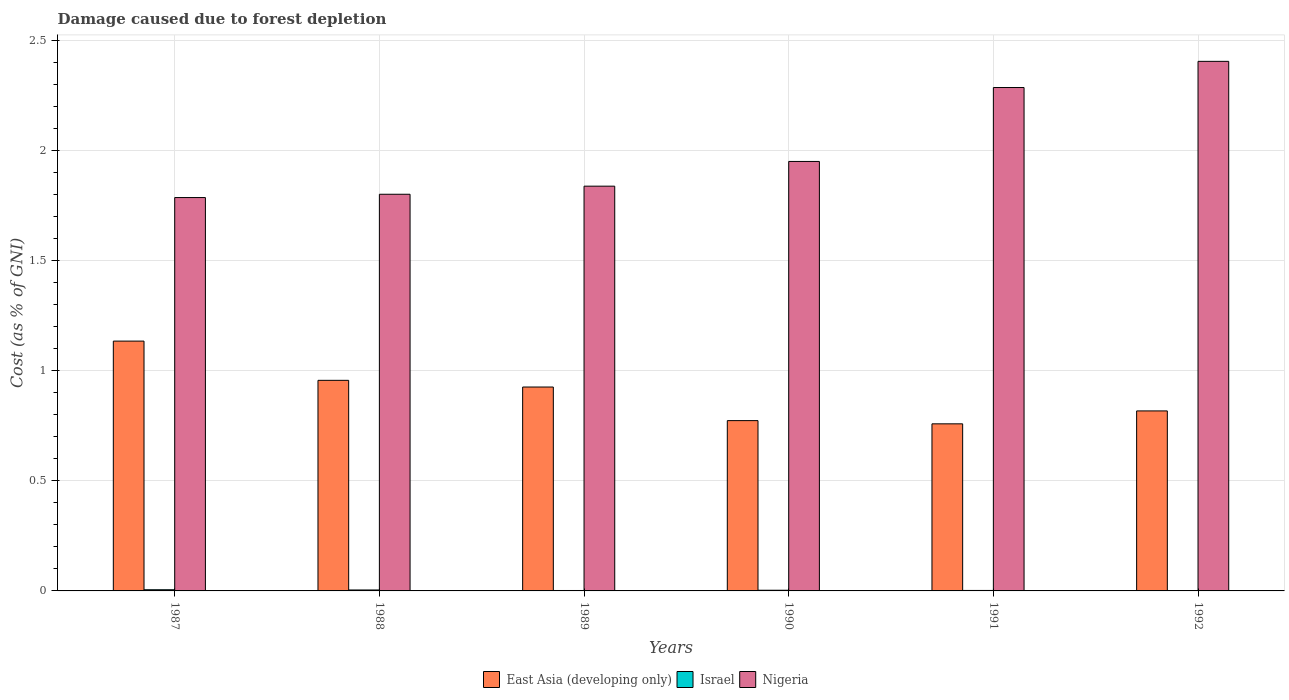How many groups of bars are there?
Your answer should be compact. 6. Are the number of bars per tick equal to the number of legend labels?
Make the answer very short. Yes. How many bars are there on the 6th tick from the left?
Give a very brief answer. 3. How many bars are there on the 1st tick from the right?
Provide a succinct answer. 3. What is the cost of damage caused due to forest depletion in East Asia (developing only) in 1989?
Keep it short and to the point. 0.93. Across all years, what is the maximum cost of damage caused due to forest depletion in East Asia (developing only)?
Give a very brief answer. 1.13. Across all years, what is the minimum cost of damage caused due to forest depletion in East Asia (developing only)?
Provide a succinct answer. 0.76. In which year was the cost of damage caused due to forest depletion in Israel maximum?
Your answer should be compact. 1987. What is the total cost of damage caused due to forest depletion in Nigeria in the graph?
Keep it short and to the point. 12.07. What is the difference between the cost of damage caused due to forest depletion in Israel in 1988 and that in 1992?
Your answer should be very brief. 0. What is the difference between the cost of damage caused due to forest depletion in Nigeria in 1988 and the cost of damage caused due to forest depletion in East Asia (developing only) in 1987?
Make the answer very short. 0.67. What is the average cost of damage caused due to forest depletion in East Asia (developing only) per year?
Offer a terse response. 0.89. In the year 1990, what is the difference between the cost of damage caused due to forest depletion in Israel and cost of damage caused due to forest depletion in Nigeria?
Provide a succinct answer. -1.95. What is the ratio of the cost of damage caused due to forest depletion in Nigeria in 1987 to that in 1988?
Offer a very short reply. 0.99. Is the cost of damage caused due to forest depletion in Nigeria in 1989 less than that in 1990?
Provide a succinct answer. Yes. What is the difference between the highest and the second highest cost of damage caused due to forest depletion in East Asia (developing only)?
Offer a terse response. 0.18. What is the difference between the highest and the lowest cost of damage caused due to forest depletion in Israel?
Keep it short and to the point. 0. Is the sum of the cost of damage caused due to forest depletion in Israel in 1988 and 1991 greater than the maximum cost of damage caused due to forest depletion in East Asia (developing only) across all years?
Give a very brief answer. No. Is it the case that in every year, the sum of the cost of damage caused due to forest depletion in Israel and cost of damage caused due to forest depletion in East Asia (developing only) is greater than the cost of damage caused due to forest depletion in Nigeria?
Offer a terse response. No. How many bars are there?
Offer a terse response. 18. Are all the bars in the graph horizontal?
Your answer should be very brief. No. What is the difference between two consecutive major ticks on the Y-axis?
Offer a very short reply. 0.5. Does the graph contain any zero values?
Your response must be concise. No. What is the title of the graph?
Give a very brief answer. Damage caused due to forest depletion. Does "Bahamas" appear as one of the legend labels in the graph?
Offer a very short reply. No. What is the label or title of the Y-axis?
Ensure brevity in your answer.  Cost (as % of GNI). What is the Cost (as % of GNI) in East Asia (developing only) in 1987?
Offer a very short reply. 1.13. What is the Cost (as % of GNI) of Israel in 1987?
Ensure brevity in your answer.  0.01. What is the Cost (as % of GNI) of Nigeria in 1987?
Provide a succinct answer. 1.79. What is the Cost (as % of GNI) in East Asia (developing only) in 1988?
Keep it short and to the point. 0.96. What is the Cost (as % of GNI) of Israel in 1988?
Give a very brief answer. 0. What is the Cost (as % of GNI) in Nigeria in 1988?
Your answer should be compact. 1.8. What is the Cost (as % of GNI) of East Asia (developing only) in 1989?
Provide a succinct answer. 0.93. What is the Cost (as % of GNI) in Israel in 1989?
Your answer should be compact. 0. What is the Cost (as % of GNI) of Nigeria in 1989?
Your answer should be compact. 1.84. What is the Cost (as % of GNI) in East Asia (developing only) in 1990?
Make the answer very short. 0.77. What is the Cost (as % of GNI) of Israel in 1990?
Offer a very short reply. 0. What is the Cost (as % of GNI) in Nigeria in 1990?
Keep it short and to the point. 1.95. What is the Cost (as % of GNI) in East Asia (developing only) in 1991?
Make the answer very short. 0.76. What is the Cost (as % of GNI) in Israel in 1991?
Keep it short and to the point. 0. What is the Cost (as % of GNI) in Nigeria in 1991?
Offer a very short reply. 2.29. What is the Cost (as % of GNI) in East Asia (developing only) in 1992?
Make the answer very short. 0.82. What is the Cost (as % of GNI) of Israel in 1992?
Your response must be concise. 0. What is the Cost (as % of GNI) of Nigeria in 1992?
Your answer should be compact. 2.41. Across all years, what is the maximum Cost (as % of GNI) in East Asia (developing only)?
Keep it short and to the point. 1.13. Across all years, what is the maximum Cost (as % of GNI) of Israel?
Your response must be concise. 0.01. Across all years, what is the maximum Cost (as % of GNI) of Nigeria?
Offer a terse response. 2.41. Across all years, what is the minimum Cost (as % of GNI) in East Asia (developing only)?
Ensure brevity in your answer.  0.76. Across all years, what is the minimum Cost (as % of GNI) in Israel?
Your answer should be very brief. 0. Across all years, what is the minimum Cost (as % of GNI) in Nigeria?
Offer a very short reply. 1.79. What is the total Cost (as % of GNI) of East Asia (developing only) in the graph?
Your answer should be compact. 5.37. What is the total Cost (as % of GNI) of Israel in the graph?
Offer a very short reply. 0.02. What is the total Cost (as % of GNI) in Nigeria in the graph?
Provide a succinct answer. 12.07. What is the difference between the Cost (as % of GNI) of East Asia (developing only) in 1987 and that in 1988?
Offer a terse response. 0.18. What is the difference between the Cost (as % of GNI) in Israel in 1987 and that in 1988?
Keep it short and to the point. 0. What is the difference between the Cost (as % of GNI) in Nigeria in 1987 and that in 1988?
Make the answer very short. -0.01. What is the difference between the Cost (as % of GNI) of East Asia (developing only) in 1987 and that in 1989?
Give a very brief answer. 0.21. What is the difference between the Cost (as % of GNI) in Israel in 1987 and that in 1989?
Make the answer very short. 0. What is the difference between the Cost (as % of GNI) in Nigeria in 1987 and that in 1989?
Offer a terse response. -0.05. What is the difference between the Cost (as % of GNI) of East Asia (developing only) in 1987 and that in 1990?
Provide a succinct answer. 0.36. What is the difference between the Cost (as % of GNI) in Israel in 1987 and that in 1990?
Make the answer very short. 0. What is the difference between the Cost (as % of GNI) of Nigeria in 1987 and that in 1990?
Your answer should be very brief. -0.16. What is the difference between the Cost (as % of GNI) in East Asia (developing only) in 1987 and that in 1991?
Offer a very short reply. 0.38. What is the difference between the Cost (as % of GNI) of Israel in 1987 and that in 1991?
Offer a terse response. 0. What is the difference between the Cost (as % of GNI) of Nigeria in 1987 and that in 1991?
Give a very brief answer. -0.5. What is the difference between the Cost (as % of GNI) of East Asia (developing only) in 1987 and that in 1992?
Make the answer very short. 0.32. What is the difference between the Cost (as % of GNI) in Israel in 1987 and that in 1992?
Ensure brevity in your answer.  0. What is the difference between the Cost (as % of GNI) in Nigeria in 1987 and that in 1992?
Your answer should be compact. -0.62. What is the difference between the Cost (as % of GNI) of East Asia (developing only) in 1988 and that in 1989?
Your response must be concise. 0.03. What is the difference between the Cost (as % of GNI) in Israel in 1988 and that in 1989?
Provide a succinct answer. 0. What is the difference between the Cost (as % of GNI) in Nigeria in 1988 and that in 1989?
Offer a terse response. -0.04. What is the difference between the Cost (as % of GNI) in East Asia (developing only) in 1988 and that in 1990?
Your response must be concise. 0.18. What is the difference between the Cost (as % of GNI) of Israel in 1988 and that in 1990?
Offer a terse response. 0. What is the difference between the Cost (as % of GNI) in Nigeria in 1988 and that in 1990?
Make the answer very short. -0.15. What is the difference between the Cost (as % of GNI) of East Asia (developing only) in 1988 and that in 1991?
Provide a short and direct response. 0.2. What is the difference between the Cost (as % of GNI) in Israel in 1988 and that in 1991?
Offer a very short reply. 0. What is the difference between the Cost (as % of GNI) in Nigeria in 1988 and that in 1991?
Offer a terse response. -0.48. What is the difference between the Cost (as % of GNI) of East Asia (developing only) in 1988 and that in 1992?
Give a very brief answer. 0.14. What is the difference between the Cost (as % of GNI) in Israel in 1988 and that in 1992?
Give a very brief answer. 0. What is the difference between the Cost (as % of GNI) in Nigeria in 1988 and that in 1992?
Keep it short and to the point. -0.6. What is the difference between the Cost (as % of GNI) in East Asia (developing only) in 1989 and that in 1990?
Make the answer very short. 0.15. What is the difference between the Cost (as % of GNI) of Israel in 1989 and that in 1990?
Make the answer very short. -0. What is the difference between the Cost (as % of GNI) of Nigeria in 1989 and that in 1990?
Your answer should be very brief. -0.11. What is the difference between the Cost (as % of GNI) in East Asia (developing only) in 1989 and that in 1991?
Offer a very short reply. 0.17. What is the difference between the Cost (as % of GNI) in Israel in 1989 and that in 1991?
Make the answer very short. -0. What is the difference between the Cost (as % of GNI) in Nigeria in 1989 and that in 1991?
Offer a terse response. -0.45. What is the difference between the Cost (as % of GNI) of East Asia (developing only) in 1989 and that in 1992?
Give a very brief answer. 0.11. What is the difference between the Cost (as % of GNI) in Israel in 1989 and that in 1992?
Offer a terse response. 0. What is the difference between the Cost (as % of GNI) of Nigeria in 1989 and that in 1992?
Your answer should be compact. -0.57. What is the difference between the Cost (as % of GNI) in East Asia (developing only) in 1990 and that in 1991?
Keep it short and to the point. 0.01. What is the difference between the Cost (as % of GNI) in Israel in 1990 and that in 1991?
Your answer should be compact. 0. What is the difference between the Cost (as % of GNI) in Nigeria in 1990 and that in 1991?
Keep it short and to the point. -0.34. What is the difference between the Cost (as % of GNI) of East Asia (developing only) in 1990 and that in 1992?
Provide a short and direct response. -0.04. What is the difference between the Cost (as % of GNI) in Israel in 1990 and that in 1992?
Give a very brief answer. 0. What is the difference between the Cost (as % of GNI) in Nigeria in 1990 and that in 1992?
Your answer should be very brief. -0.45. What is the difference between the Cost (as % of GNI) of East Asia (developing only) in 1991 and that in 1992?
Provide a succinct answer. -0.06. What is the difference between the Cost (as % of GNI) in Nigeria in 1991 and that in 1992?
Offer a terse response. -0.12. What is the difference between the Cost (as % of GNI) in East Asia (developing only) in 1987 and the Cost (as % of GNI) in Israel in 1988?
Your response must be concise. 1.13. What is the difference between the Cost (as % of GNI) of East Asia (developing only) in 1987 and the Cost (as % of GNI) of Nigeria in 1988?
Give a very brief answer. -0.67. What is the difference between the Cost (as % of GNI) of Israel in 1987 and the Cost (as % of GNI) of Nigeria in 1988?
Provide a succinct answer. -1.8. What is the difference between the Cost (as % of GNI) in East Asia (developing only) in 1987 and the Cost (as % of GNI) in Israel in 1989?
Provide a short and direct response. 1.13. What is the difference between the Cost (as % of GNI) in East Asia (developing only) in 1987 and the Cost (as % of GNI) in Nigeria in 1989?
Offer a terse response. -0.7. What is the difference between the Cost (as % of GNI) in Israel in 1987 and the Cost (as % of GNI) in Nigeria in 1989?
Make the answer very short. -1.83. What is the difference between the Cost (as % of GNI) in East Asia (developing only) in 1987 and the Cost (as % of GNI) in Israel in 1990?
Your answer should be very brief. 1.13. What is the difference between the Cost (as % of GNI) of East Asia (developing only) in 1987 and the Cost (as % of GNI) of Nigeria in 1990?
Provide a short and direct response. -0.82. What is the difference between the Cost (as % of GNI) of Israel in 1987 and the Cost (as % of GNI) of Nigeria in 1990?
Make the answer very short. -1.95. What is the difference between the Cost (as % of GNI) in East Asia (developing only) in 1987 and the Cost (as % of GNI) in Israel in 1991?
Make the answer very short. 1.13. What is the difference between the Cost (as % of GNI) of East Asia (developing only) in 1987 and the Cost (as % of GNI) of Nigeria in 1991?
Your response must be concise. -1.15. What is the difference between the Cost (as % of GNI) in Israel in 1987 and the Cost (as % of GNI) in Nigeria in 1991?
Provide a succinct answer. -2.28. What is the difference between the Cost (as % of GNI) in East Asia (developing only) in 1987 and the Cost (as % of GNI) in Israel in 1992?
Your response must be concise. 1.13. What is the difference between the Cost (as % of GNI) in East Asia (developing only) in 1987 and the Cost (as % of GNI) in Nigeria in 1992?
Provide a short and direct response. -1.27. What is the difference between the Cost (as % of GNI) of Israel in 1987 and the Cost (as % of GNI) of Nigeria in 1992?
Make the answer very short. -2.4. What is the difference between the Cost (as % of GNI) in East Asia (developing only) in 1988 and the Cost (as % of GNI) in Israel in 1989?
Your answer should be compact. 0.95. What is the difference between the Cost (as % of GNI) of East Asia (developing only) in 1988 and the Cost (as % of GNI) of Nigeria in 1989?
Your answer should be very brief. -0.88. What is the difference between the Cost (as % of GNI) of Israel in 1988 and the Cost (as % of GNI) of Nigeria in 1989?
Make the answer very short. -1.83. What is the difference between the Cost (as % of GNI) in East Asia (developing only) in 1988 and the Cost (as % of GNI) in Israel in 1990?
Make the answer very short. 0.95. What is the difference between the Cost (as % of GNI) of East Asia (developing only) in 1988 and the Cost (as % of GNI) of Nigeria in 1990?
Your answer should be very brief. -0.99. What is the difference between the Cost (as % of GNI) in Israel in 1988 and the Cost (as % of GNI) in Nigeria in 1990?
Make the answer very short. -1.95. What is the difference between the Cost (as % of GNI) of East Asia (developing only) in 1988 and the Cost (as % of GNI) of Israel in 1991?
Ensure brevity in your answer.  0.95. What is the difference between the Cost (as % of GNI) of East Asia (developing only) in 1988 and the Cost (as % of GNI) of Nigeria in 1991?
Give a very brief answer. -1.33. What is the difference between the Cost (as % of GNI) of Israel in 1988 and the Cost (as % of GNI) of Nigeria in 1991?
Give a very brief answer. -2.28. What is the difference between the Cost (as % of GNI) of East Asia (developing only) in 1988 and the Cost (as % of GNI) of Israel in 1992?
Ensure brevity in your answer.  0.95. What is the difference between the Cost (as % of GNI) in East Asia (developing only) in 1988 and the Cost (as % of GNI) in Nigeria in 1992?
Keep it short and to the point. -1.45. What is the difference between the Cost (as % of GNI) of Israel in 1988 and the Cost (as % of GNI) of Nigeria in 1992?
Keep it short and to the point. -2.4. What is the difference between the Cost (as % of GNI) in East Asia (developing only) in 1989 and the Cost (as % of GNI) in Israel in 1990?
Make the answer very short. 0.92. What is the difference between the Cost (as % of GNI) in East Asia (developing only) in 1989 and the Cost (as % of GNI) in Nigeria in 1990?
Provide a succinct answer. -1.02. What is the difference between the Cost (as % of GNI) in Israel in 1989 and the Cost (as % of GNI) in Nigeria in 1990?
Your response must be concise. -1.95. What is the difference between the Cost (as % of GNI) of East Asia (developing only) in 1989 and the Cost (as % of GNI) of Israel in 1991?
Ensure brevity in your answer.  0.92. What is the difference between the Cost (as % of GNI) in East Asia (developing only) in 1989 and the Cost (as % of GNI) in Nigeria in 1991?
Ensure brevity in your answer.  -1.36. What is the difference between the Cost (as % of GNI) in Israel in 1989 and the Cost (as % of GNI) in Nigeria in 1991?
Keep it short and to the point. -2.29. What is the difference between the Cost (as % of GNI) of East Asia (developing only) in 1989 and the Cost (as % of GNI) of Israel in 1992?
Provide a succinct answer. 0.92. What is the difference between the Cost (as % of GNI) of East Asia (developing only) in 1989 and the Cost (as % of GNI) of Nigeria in 1992?
Your answer should be compact. -1.48. What is the difference between the Cost (as % of GNI) in Israel in 1989 and the Cost (as % of GNI) in Nigeria in 1992?
Keep it short and to the point. -2.4. What is the difference between the Cost (as % of GNI) in East Asia (developing only) in 1990 and the Cost (as % of GNI) in Israel in 1991?
Your answer should be compact. 0.77. What is the difference between the Cost (as % of GNI) in East Asia (developing only) in 1990 and the Cost (as % of GNI) in Nigeria in 1991?
Your response must be concise. -1.51. What is the difference between the Cost (as % of GNI) in Israel in 1990 and the Cost (as % of GNI) in Nigeria in 1991?
Provide a succinct answer. -2.28. What is the difference between the Cost (as % of GNI) of East Asia (developing only) in 1990 and the Cost (as % of GNI) of Israel in 1992?
Provide a short and direct response. 0.77. What is the difference between the Cost (as % of GNI) in East Asia (developing only) in 1990 and the Cost (as % of GNI) in Nigeria in 1992?
Keep it short and to the point. -1.63. What is the difference between the Cost (as % of GNI) of Israel in 1990 and the Cost (as % of GNI) of Nigeria in 1992?
Your answer should be very brief. -2.4. What is the difference between the Cost (as % of GNI) in East Asia (developing only) in 1991 and the Cost (as % of GNI) in Israel in 1992?
Provide a short and direct response. 0.76. What is the difference between the Cost (as % of GNI) of East Asia (developing only) in 1991 and the Cost (as % of GNI) of Nigeria in 1992?
Your answer should be very brief. -1.65. What is the difference between the Cost (as % of GNI) in Israel in 1991 and the Cost (as % of GNI) in Nigeria in 1992?
Your answer should be compact. -2.4. What is the average Cost (as % of GNI) in East Asia (developing only) per year?
Keep it short and to the point. 0.89. What is the average Cost (as % of GNI) of Israel per year?
Your answer should be very brief. 0. What is the average Cost (as % of GNI) of Nigeria per year?
Your response must be concise. 2.01. In the year 1987, what is the difference between the Cost (as % of GNI) of East Asia (developing only) and Cost (as % of GNI) of Israel?
Give a very brief answer. 1.13. In the year 1987, what is the difference between the Cost (as % of GNI) of East Asia (developing only) and Cost (as % of GNI) of Nigeria?
Offer a terse response. -0.65. In the year 1987, what is the difference between the Cost (as % of GNI) of Israel and Cost (as % of GNI) of Nigeria?
Keep it short and to the point. -1.78. In the year 1988, what is the difference between the Cost (as % of GNI) in East Asia (developing only) and Cost (as % of GNI) in Nigeria?
Your answer should be compact. -0.85. In the year 1988, what is the difference between the Cost (as % of GNI) in Israel and Cost (as % of GNI) in Nigeria?
Offer a very short reply. -1.8. In the year 1989, what is the difference between the Cost (as % of GNI) in East Asia (developing only) and Cost (as % of GNI) in Israel?
Offer a terse response. 0.92. In the year 1989, what is the difference between the Cost (as % of GNI) in East Asia (developing only) and Cost (as % of GNI) in Nigeria?
Keep it short and to the point. -0.91. In the year 1989, what is the difference between the Cost (as % of GNI) in Israel and Cost (as % of GNI) in Nigeria?
Provide a short and direct response. -1.84. In the year 1990, what is the difference between the Cost (as % of GNI) of East Asia (developing only) and Cost (as % of GNI) of Israel?
Provide a succinct answer. 0.77. In the year 1990, what is the difference between the Cost (as % of GNI) of East Asia (developing only) and Cost (as % of GNI) of Nigeria?
Your answer should be compact. -1.18. In the year 1990, what is the difference between the Cost (as % of GNI) in Israel and Cost (as % of GNI) in Nigeria?
Your response must be concise. -1.95. In the year 1991, what is the difference between the Cost (as % of GNI) in East Asia (developing only) and Cost (as % of GNI) in Israel?
Offer a very short reply. 0.76. In the year 1991, what is the difference between the Cost (as % of GNI) of East Asia (developing only) and Cost (as % of GNI) of Nigeria?
Offer a very short reply. -1.53. In the year 1991, what is the difference between the Cost (as % of GNI) of Israel and Cost (as % of GNI) of Nigeria?
Your answer should be compact. -2.28. In the year 1992, what is the difference between the Cost (as % of GNI) in East Asia (developing only) and Cost (as % of GNI) in Israel?
Provide a succinct answer. 0.82. In the year 1992, what is the difference between the Cost (as % of GNI) of East Asia (developing only) and Cost (as % of GNI) of Nigeria?
Make the answer very short. -1.59. In the year 1992, what is the difference between the Cost (as % of GNI) of Israel and Cost (as % of GNI) of Nigeria?
Ensure brevity in your answer.  -2.4. What is the ratio of the Cost (as % of GNI) of East Asia (developing only) in 1987 to that in 1988?
Your response must be concise. 1.19. What is the ratio of the Cost (as % of GNI) of Israel in 1987 to that in 1988?
Your response must be concise. 1.25. What is the ratio of the Cost (as % of GNI) in East Asia (developing only) in 1987 to that in 1989?
Your answer should be very brief. 1.23. What is the ratio of the Cost (as % of GNI) in Israel in 1987 to that in 1989?
Keep it short and to the point. 2.75. What is the ratio of the Cost (as % of GNI) in Nigeria in 1987 to that in 1989?
Your answer should be very brief. 0.97. What is the ratio of the Cost (as % of GNI) of East Asia (developing only) in 1987 to that in 1990?
Give a very brief answer. 1.47. What is the ratio of the Cost (as % of GNI) of Israel in 1987 to that in 1990?
Offer a terse response. 1.74. What is the ratio of the Cost (as % of GNI) in Nigeria in 1987 to that in 1990?
Your answer should be compact. 0.92. What is the ratio of the Cost (as % of GNI) of East Asia (developing only) in 1987 to that in 1991?
Provide a succinct answer. 1.5. What is the ratio of the Cost (as % of GNI) of Israel in 1987 to that in 1991?
Your response must be concise. 2.53. What is the ratio of the Cost (as % of GNI) of Nigeria in 1987 to that in 1991?
Ensure brevity in your answer.  0.78. What is the ratio of the Cost (as % of GNI) of East Asia (developing only) in 1987 to that in 1992?
Your answer should be compact. 1.39. What is the ratio of the Cost (as % of GNI) in Israel in 1987 to that in 1992?
Your answer should be very brief. 2.96. What is the ratio of the Cost (as % of GNI) in Nigeria in 1987 to that in 1992?
Provide a succinct answer. 0.74. What is the ratio of the Cost (as % of GNI) of East Asia (developing only) in 1988 to that in 1989?
Your answer should be very brief. 1.03. What is the ratio of the Cost (as % of GNI) in Israel in 1988 to that in 1989?
Make the answer very short. 2.2. What is the ratio of the Cost (as % of GNI) of Nigeria in 1988 to that in 1989?
Provide a succinct answer. 0.98. What is the ratio of the Cost (as % of GNI) in East Asia (developing only) in 1988 to that in 1990?
Your answer should be very brief. 1.24. What is the ratio of the Cost (as % of GNI) of Israel in 1988 to that in 1990?
Keep it short and to the point. 1.39. What is the ratio of the Cost (as % of GNI) in Nigeria in 1988 to that in 1990?
Provide a succinct answer. 0.92. What is the ratio of the Cost (as % of GNI) of East Asia (developing only) in 1988 to that in 1991?
Give a very brief answer. 1.26. What is the ratio of the Cost (as % of GNI) in Israel in 1988 to that in 1991?
Keep it short and to the point. 2.03. What is the ratio of the Cost (as % of GNI) in Nigeria in 1988 to that in 1991?
Provide a short and direct response. 0.79. What is the ratio of the Cost (as % of GNI) of East Asia (developing only) in 1988 to that in 1992?
Make the answer very short. 1.17. What is the ratio of the Cost (as % of GNI) of Israel in 1988 to that in 1992?
Offer a terse response. 2.38. What is the ratio of the Cost (as % of GNI) of Nigeria in 1988 to that in 1992?
Make the answer very short. 0.75. What is the ratio of the Cost (as % of GNI) of East Asia (developing only) in 1989 to that in 1990?
Keep it short and to the point. 1.2. What is the ratio of the Cost (as % of GNI) in Israel in 1989 to that in 1990?
Provide a short and direct response. 0.63. What is the ratio of the Cost (as % of GNI) of Nigeria in 1989 to that in 1990?
Make the answer very short. 0.94. What is the ratio of the Cost (as % of GNI) in East Asia (developing only) in 1989 to that in 1991?
Your answer should be compact. 1.22. What is the ratio of the Cost (as % of GNI) in Israel in 1989 to that in 1991?
Give a very brief answer. 0.92. What is the ratio of the Cost (as % of GNI) in Nigeria in 1989 to that in 1991?
Keep it short and to the point. 0.8. What is the ratio of the Cost (as % of GNI) of East Asia (developing only) in 1989 to that in 1992?
Provide a short and direct response. 1.13. What is the ratio of the Cost (as % of GNI) of Israel in 1989 to that in 1992?
Provide a succinct answer. 1.08. What is the ratio of the Cost (as % of GNI) of Nigeria in 1989 to that in 1992?
Give a very brief answer. 0.76. What is the ratio of the Cost (as % of GNI) in East Asia (developing only) in 1990 to that in 1991?
Provide a succinct answer. 1.02. What is the ratio of the Cost (as % of GNI) in Israel in 1990 to that in 1991?
Offer a very short reply. 1.45. What is the ratio of the Cost (as % of GNI) in Nigeria in 1990 to that in 1991?
Keep it short and to the point. 0.85. What is the ratio of the Cost (as % of GNI) in East Asia (developing only) in 1990 to that in 1992?
Offer a very short reply. 0.95. What is the ratio of the Cost (as % of GNI) of Israel in 1990 to that in 1992?
Your answer should be compact. 1.71. What is the ratio of the Cost (as % of GNI) in Nigeria in 1990 to that in 1992?
Your response must be concise. 0.81. What is the ratio of the Cost (as % of GNI) in East Asia (developing only) in 1991 to that in 1992?
Your answer should be very brief. 0.93. What is the ratio of the Cost (as % of GNI) of Israel in 1991 to that in 1992?
Offer a very short reply. 1.17. What is the ratio of the Cost (as % of GNI) of Nigeria in 1991 to that in 1992?
Provide a short and direct response. 0.95. What is the difference between the highest and the second highest Cost (as % of GNI) of East Asia (developing only)?
Make the answer very short. 0.18. What is the difference between the highest and the second highest Cost (as % of GNI) in Israel?
Offer a very short reply. 0. What is the difference between the highest and the second highest Cost (as % of GNI) of Nigeria?
Offer a terse response. 0.12. What is the difference between the highest and the lowest Cost (as % of GNI) in East Asia (developing only)?
Ensure brevity in your answer.  0.38. What is the difference between the highest and the lowest Cost (as % of GNI) in Israel?
Your answer should be compact. 0. What is the difference between the highest and the lowest Cost (as % of GNI) of Nigeria?
Make the answer very short. 0.62. 